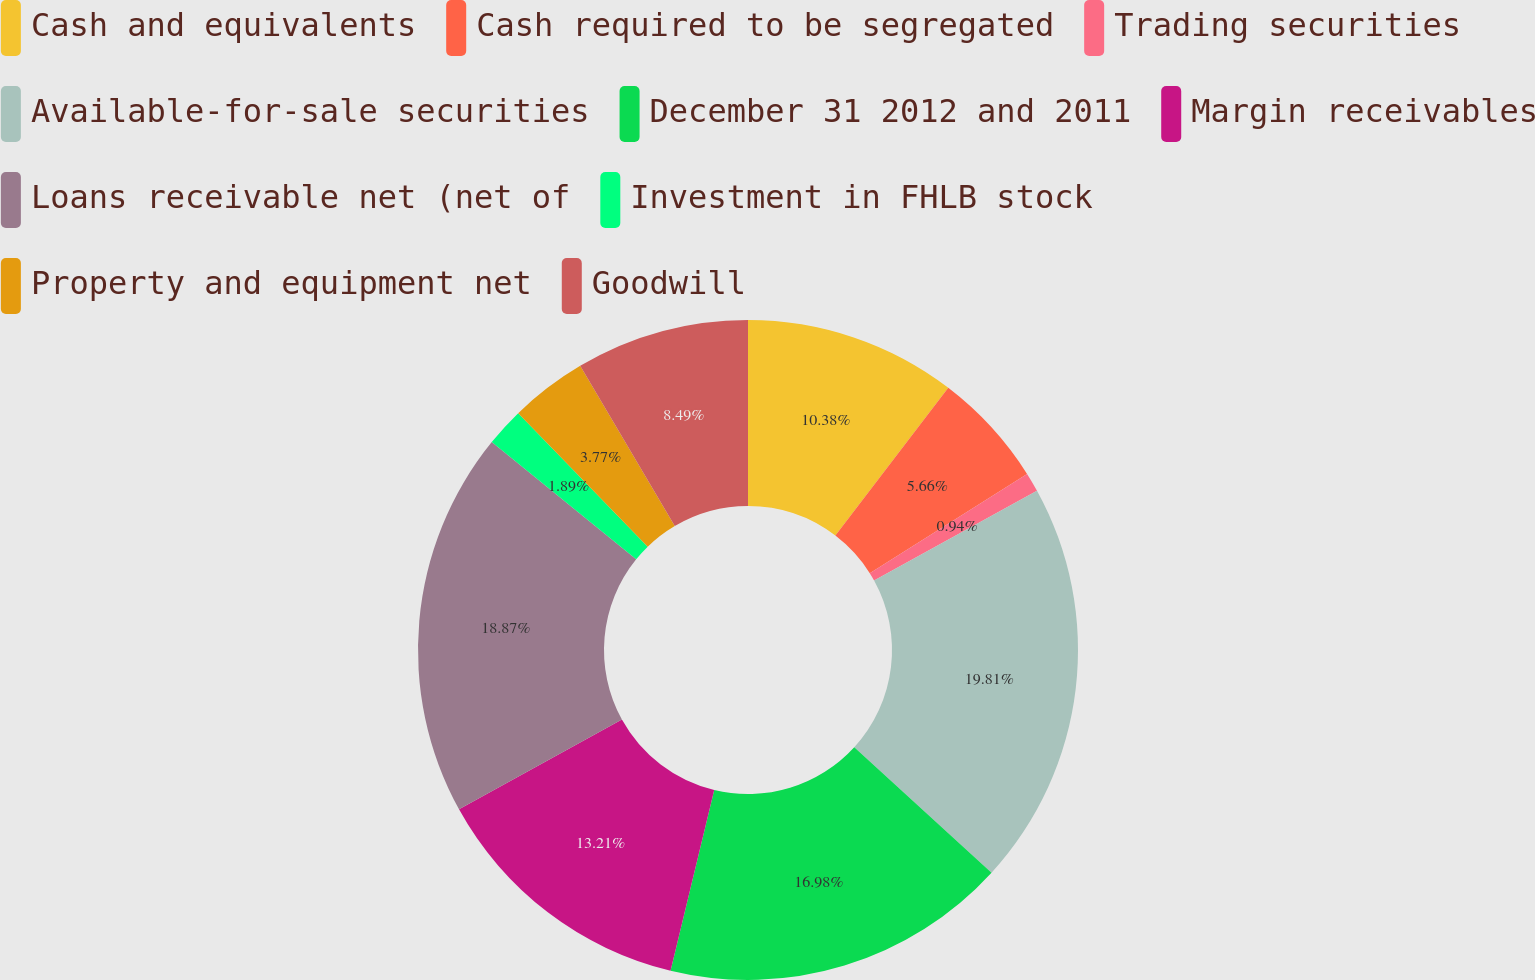<chart> <loc_0><loc_0><loc_500><loc_500><pie_chart><fcel>Cash and equivalents<fcel>Cash required to be segregated<fcel>Trading securities<fcel>Available-for-sale securities<fcel>December 31 2012 and 2011<fcel>Margin receivables<fcel>Loans receivable net (net of<fcel>Investment in FHLB stock<fcel>Property and equipment net<fcel>Goodwill<nl><fcel>10.38%<fcel>5.66%<fcel>0.94%<fcel>19.81%<fcel>16.98%<fcel>13.21%<fcel>18.87%<fcel>1.89%<fcel>3.77%<fcel>8.49%<nl></chart> 